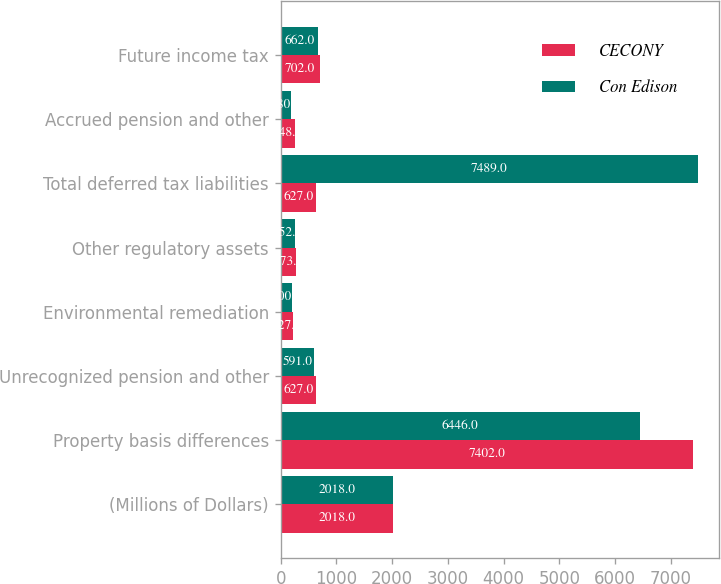Convert chart. <chart><loc_0><loc_0><loc_500><loc_500><stacked_bar_chart><ecel><fcel>(Millions of Dollars)<fcel>Property basis differences<fcel>Unrecognized pension and other<fcel>Environmental remediation<fcel>Other regulatory assets<fcel>Total deferred tax liabilities<fcel>Accrued pension and other<fcel>Future income tax<nl><fcel>CECONY<fcel>2018<fcel>7402<fcel>627<fcel>227<fcel>273<fcel>627<fcel>248<fcel>702<nl><fcel>Con Edison<fcel>2018<fcel>6446<fcel>591<fcel>200<fcel>252<fcel>7489<fcel>180<fcel>662<nl></chart> 